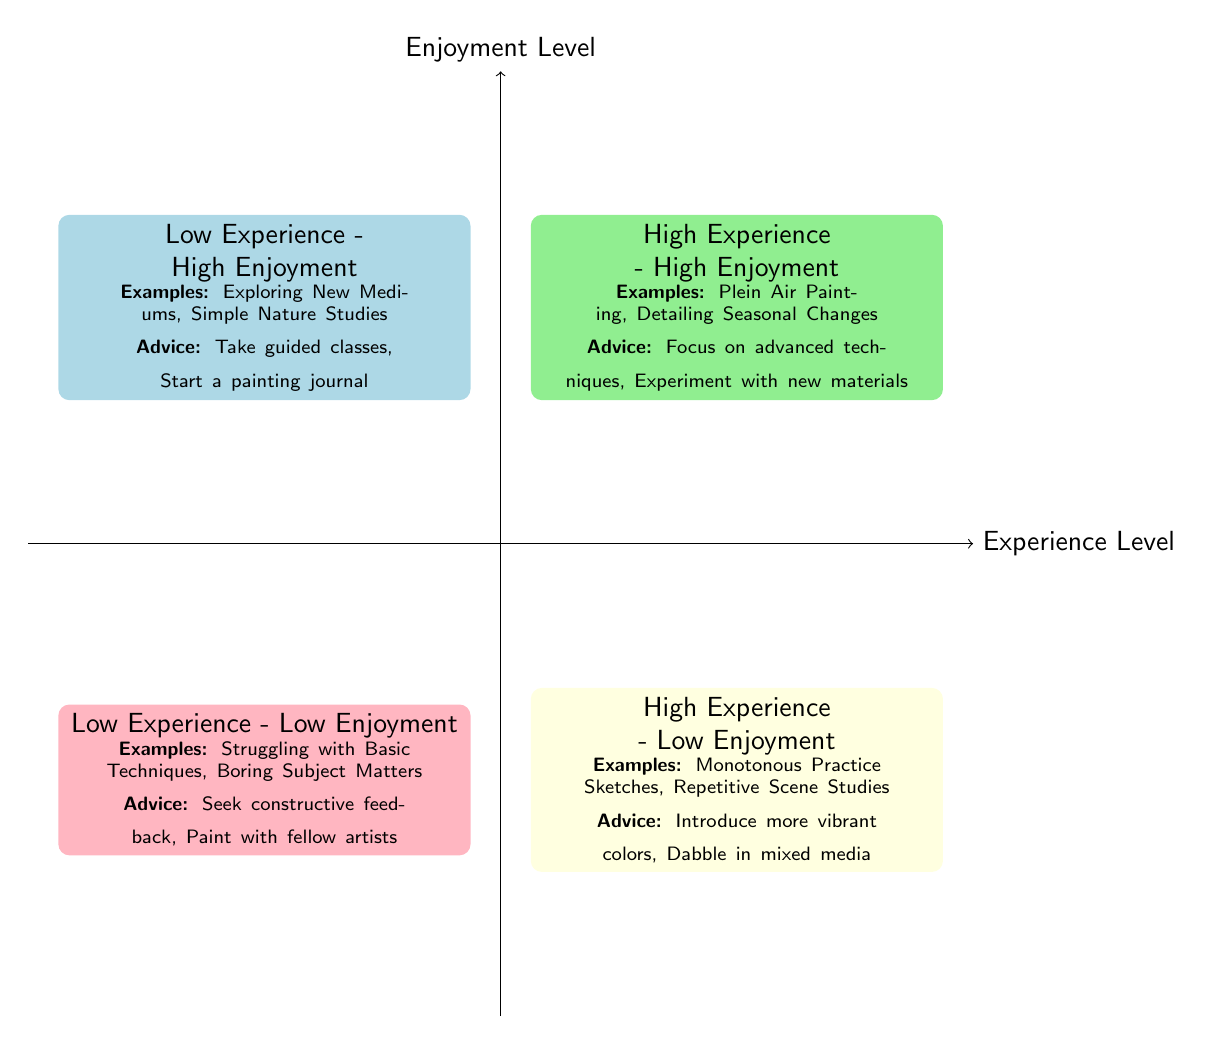What are the examples listed in the High Experience - High Enjoyment quadrant? The diagram specifies two examples: "Plein Air Painting" and "Detailing Seasonal Changes" located in the High Experience - High Enjoyment section.
Answer: Plein Air Painting, Detailing Seasonal Changes Which quadrant contains examples of Low Experience and High Enjoyment? By examining the quadrant labels on the chart, the Low Experience - High Enjoyment quadrant is located in the top left area, which includes examples like "Exploring New Mediums" and "Simple Nature Studies."
Answer: Low Experience - High Enjoyment What advice is given for individuals in the High Experience - Low Enjoyment quadrant? The High Experience - Low Enjoyment quadrant highlights the advice "Introduce more vibrant colors" and "Dabble in mixed media" based on the information provided in that section.
Answer: Introduce more vibrant colors, Dabble in mixed media How many quadrants are represented in the diagram? The chart clearly divides the information into four distinct quadrants labeled by different experience and enjoyment levels: High Experience - High Enjoyment, High Experience - Low Enjoyment, Low Experience - High Enjoyment, and Low Experience - Low Enjoyment.
Answer: Four In which quadrant would you find "Struggling with Basic Techniques"? This specific phrase is mentioned in the Low Experience - Low Enjoyment quadrant, indicating that it represents a situation where both enjoyment and experience are lacking.
Answer: Low Experience - Low Enjoyment What type of painting sessions does the Low Experience - High Enjoyment quadrant suggest to take guided classes? The Low Experience - High Enjoyment quadrant suggests "Exploring New Mediums" and "Simple Nature Studies," which indicate activities suitable for those new to painting and aiming to increase enjoyment while developing skills.
Answer: Exploring New Mediums, Simple Nature Studies What common advice can be found in both the High Experience - High Enjoyment and Low Experience - Low Enjoyment quadrants? While examining both quadrants, it is clear that High Experience - High Enjoyment suggests experimenting with new materials, while Low Experience - Low Enjoyment advises seeking constructive feedback, indicating a focus on improving one’s painting approach.
Answer: None, they suggest different strategies Which quadrant would suggest painting with fellow artists for improvement? The advice to "Paint with fellow artists" is found in the Low Experience - Low Enjoyment quadrant, indicating that collaboration could enhance skills and overall enjoyment in that context.
Answer: Low Experience - Low Enjoyment 